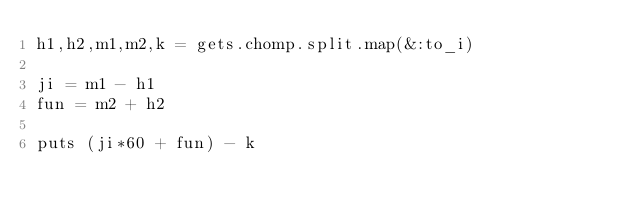<code> <loc_0><loc_0><loc_500><loc_500><_Ruby_>h1,h2,m1,m2,k = gets.chomp.split.map(&:to_i)

ji = m1 - h1
fun = m2 + h2

puts (ji*60 + fun) - k</code> 